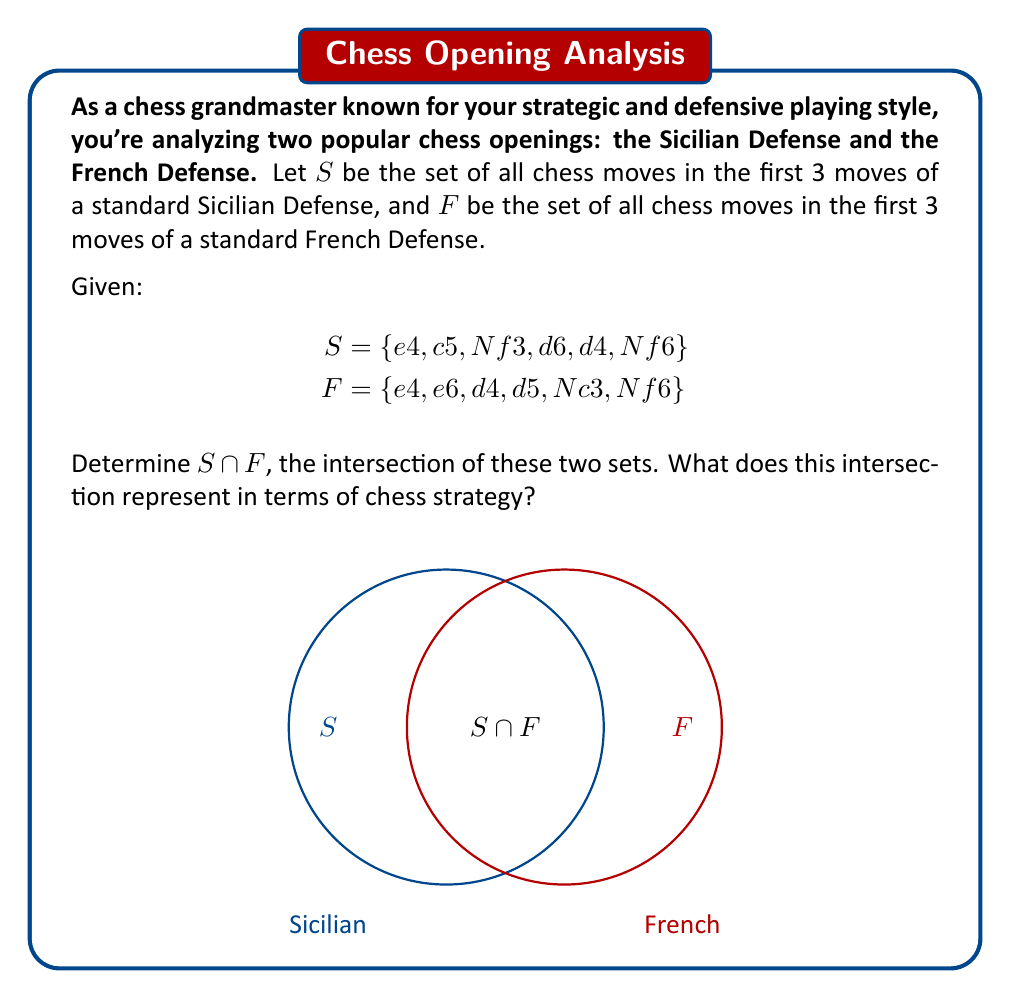Teach me how to tackle this problem. To find the intersection of sets $S$ and $F$, we need to identify the elements that are common to both sets.

Step 1: List out the elements of each set.
$S = \{e4, c5, Nf3, d6, d4, Nf6\}$
$F = \{e4, e6, d4, d5, Nc3, Nf6\}$

Step 2: Identify the common elements.
The common elements are: $e4$, $d4$, and $Nf6$

Step 3: Write the intersection.
$S \cap F = \{e4, d4, Nf6\}$

In terms of chess strategy, this intersection represents the moves that are common to both the Sicilian Defense and the French Defense in their opening stages. Specifically:

1. $e4$: White's common opening move, moving the king's pawn two squares forward.
2. $d4$: A central pawn push by White, often used to control the center.
3. $Nf6$: Black's knight development to f6, a flexible move that attacks the center and prepares for castling.

These common elements show that despite being different defenses, both openings share some strategic elements, such as fighting for central control and developing pieces quickly.
Answer: $S \cap F = \{e4, d4, Nf6\}$ 